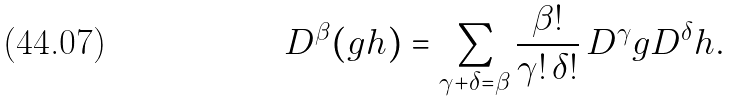Convert formula to latex. <formula><loc_0><loc_0><loc_500><loc_500>D ^ { \beta } ( g h ) = \sum _ { \gamma + \delta = \beta } \frac { \beta ! } { \gamma ! \, \delta ! } \, D ^ { \gamma } g D ^ { \delta } h .</formula> 